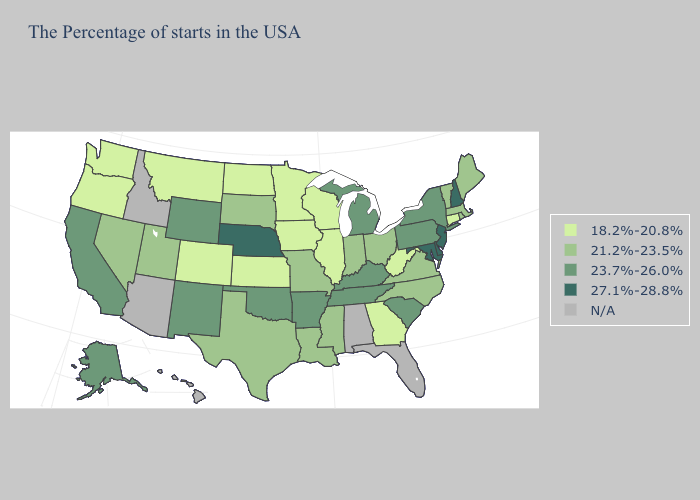Does Nebraska have the highest value in the MidWest?
Write a very short answer. Yes. Among the states that border Louisiana , does Texas have the lowest value?
Give a very brief answer. Yes. Does Minnesota have the highest value in the MidWest?
Keep it brief. No. Does Iowa have the lowest value in the MidWest?
Answer briefly. Yes. Does Louisiana have the lowest value in the USA?
Quick response, please. No. Among the states that border Delaware , does New Jersey have the highest value?
Short answer required. Yes. What is the highest value in states that border Colorado?
Concise answer only. 27.1%-28.8%. What is the value of Tennessee?
Short answer required. 23.7%-26.0%. Name the states that have a value in the range 21.2%-23.5%?
Be succinct. Maine, Massachusetts, Rhode Island, Vermont, Virginia, North Carolina, Ohio, Indiana, Mississippi, Louisiana, Missouri, Texas, South Dakota, Utah, Nevada. Among the states that border Virginia , does Maryland have the highest value?
Write a very short answer. Yes. Name the states that have a value in the range N/A?
Give a very brief answer. Florida, Alabama, Arizona, Idaho, Hawaii. What is the value of Idaho?
Give a very brief answer. N/A. Which states have the highest value in the USA?
Quick response, please. New Hampshire, New Jersey, Delaware, Maryland, Nebraska. What is the highest value in the West ?
Short answer required. 23.7%-26.0%. What is the highest value in the USA?
Quick response, please. 27.1%-28.8%. 